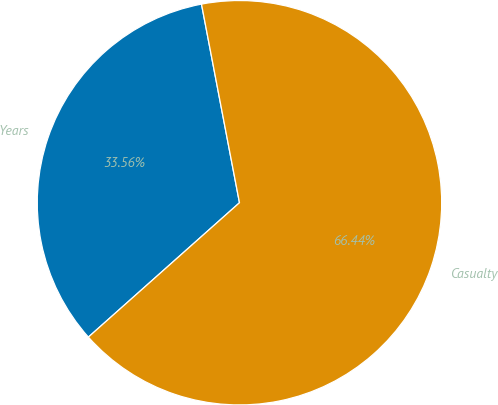Convert chart to OTSL. <chart><loc_0><loc_0><loc_500><loc_500><pie_chart><fcel>Years<fcel>Casualty<nl><fcel>33.56%<fcel>66.44%<nl></chart> 